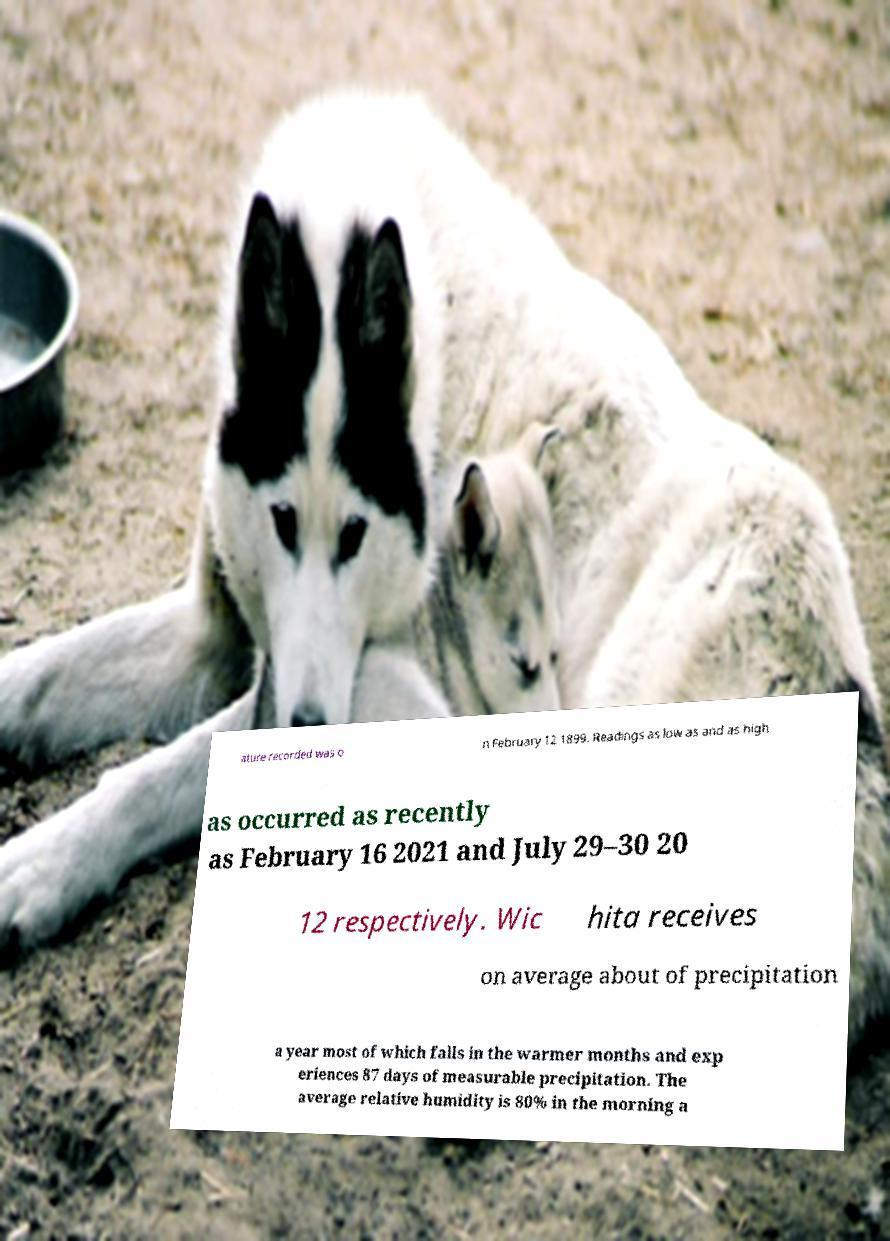Can you read and provide the text displayed in the image?This photo seems to have some interesting text. Can you extract and type it out for me? ature recorded was o n February 12 1899. Readings as low as and as high as occurred as recently as February 16 2021 and July 29–30 20 12 respectively. Wic hita receives on average about of precipitation a year most of which falls in the warmer months and exp eriences 87 days of measurable precipitation. The average relative humidity is 80% in the morning a 